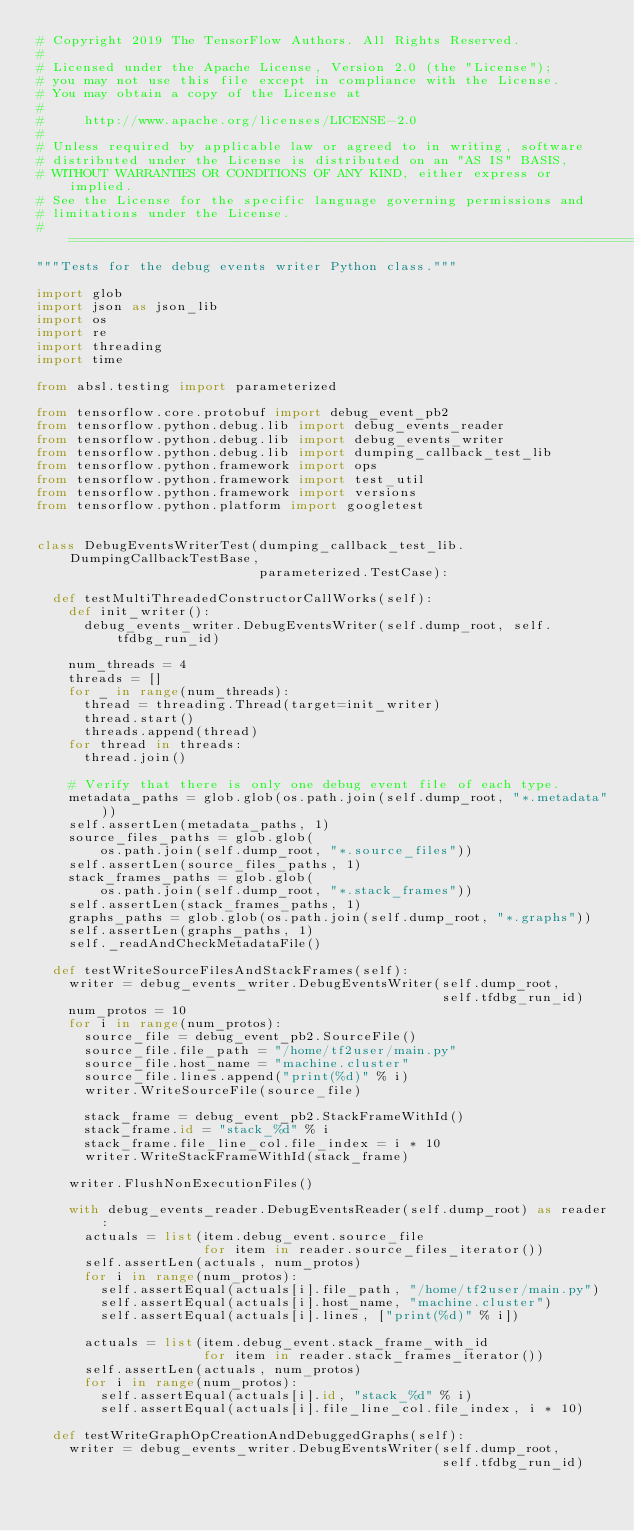<code> <loc_0><loc_0><loc_500><loc_500><_Python_># Copyright 2019 The TensorFlow Authors. All Rights Reserved.
#
# Licensed under the Apache License, Version 2.0 (the "License");
# you may not use this file except in compliance with the License.
# You may obtain a copy of the License at
#
#     http://www.apache.org/licenses/LICENSE-2.0
#
# Unless required by applicable law or agreed to in writing, software
# distributed under the License is distributed on an "AS IS" BASIS,
# WITHOUT WARRANTIES OR CONDITIONS OF ANY KIND, either express or implied.
# See the License for the specific language governing permissions and
# limitations under the License.
# ==============================================================================
"""Tests for the debug events writer Python class."""

import glob
import json as json_lib
import os
import re
import threading
import time

from absl.testing import parameterized

from tensorflow.core.protobuf import debug_event_pb2
from tensorflow.python.debug.lib import debug_events_reader
from tensorflow.python.debug.lib import debug_events_writer
from tensorflow.python.debug.lib import dumping_callback_test_lib
from tensorflow.python.framework import ops
from tensorflow.python.framework import test_util
from tensorflow.python.framework import versions
from tensorflow.python.platform import googletest


class DebugEventsWriterTest(dumping_callback_test_lib.DumpingCallbackTestBase,
                            parameterized.TestCase):

  def testMultiThreadedConstructorCallWorks(self):
    def init_writer():
      debug_events_writer.DebugEventsWriter(self.dump_root, self.tfdbg_run_id)

    num_threads = 4
    threads = []
    for _ in range(num_threads):
      thread = threading.Thread(target=init_writer)
      thread.start()
      threads.append(thread)
    for thread in threads:
      thread.join()

    # Verify that there is only one debug event file of each type.
    metadata_paths = glob.glob(os.path.join(self.dump_root, "*.metadata"))
    self.assertLen(metadata_paths, 1)
    source_files_paths = glob.glob(
        os.path.join(self.dump_root, "*.source_files"))
    self.assertLen(source_files_paths, 1)
    stack_frames_paths = glob.glob(
        os.path.join(self.dump_root, "*.stack_frames"))
    self.assertLen(stack_frames_paths, 1)
    graphs_paths = glob.glob(os.path.join(self.dump_root, "*.graphs"))
    self.assertLen(graphs_paths, 1)
    self._readAndCheckMetadataFile()

  def testWriteSourceFilesAndStackFrames(self):
    writer = debug_events_writer.DebugEventsWriter(self.dump_root,
                                                   self.tfdbg_run_id)
    num_protos = 10
    for i in range(num_protos):
      source_file = debug_event_pb2.SourceFile()
      source_file.file_path = "/home/tf2user/main.py"
      source_file.host_name = "machine.cluster"
      source_file.lines.append("print(%d)" % i)
      writer.WriteSourceFile(source_file)

      stack_frame = debug_event_pb2.StackFrameWithId()
      stack_frame.id = "stack_%d" % i
      stack_frame.file_line_col.file_index = i * 10
      writer.WriteStackFrameWithId(stack_frame)

    writer.FlushNonExecutionFiles()

    with debug_events_reader.DebugEventsReader(self.dump_root) as reader:
      actuals = list(item.debug_event.source_file
                     for item in reader.source_files_iterator())
      self.assertLen(actuals, num_protos)
      for i in range(num_protos):
        self.assertEqual(actuals[i].file_path, "/home/tf2user/main.py")
        self.assertEqual(actuals[i].host_name, "machine.cluster")
        self.assertEqual(actuals[i].lines, ["print(%d)" % i])

      actuals = list(item.debug_event.stack_frame_with_id
                     for item in reader.stack_frames_iterator())
      self.assertLen(actuals, num_protos)
      for i in range(num_protos):
        self.assertEqual(actuals[i].id, "stack_%d" % i)
        self.assertEqual(actuals[i].file_line_col.file_index, i * 10)

  def testWriteGraphOpCreationAndDebuggedGraphs(self):
    writer = debug_events_writer.DebugEventsWriter(self.dump_root,
                                                   self.tfdbg_run_id)</code> 